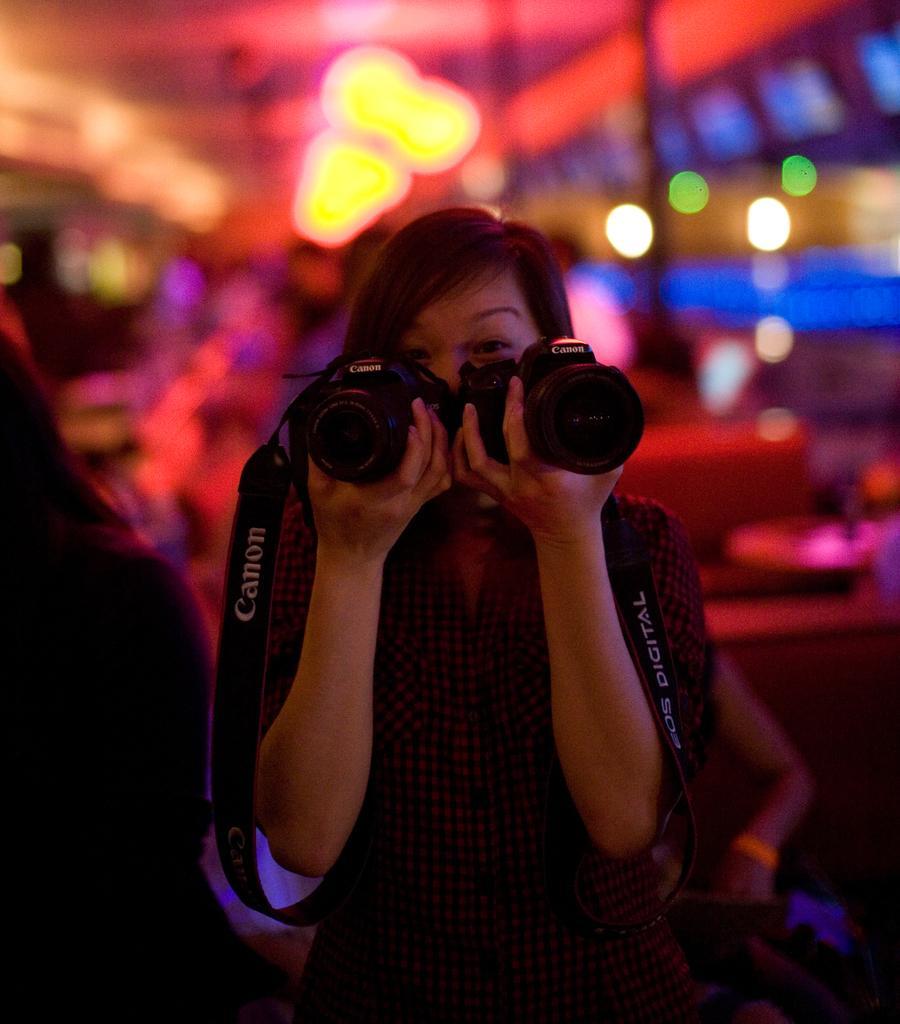In one or two sentences, can you explain what this image depicts? This picture shows a woman, holding two cameras in her hands. In the background there are some lights. 